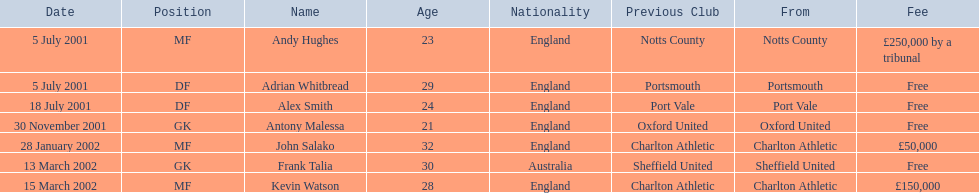Who are all the players? Andy Hughes, Adrian Whitbread, Alex Smith, Antony Malessa, John Salako, Frank Talia, Kevin Watson. What were their fees? £250,000 by a tribunal, Free, Free, Free, £50,000, Free, £150,000. Parse the full table. {'header': ['Date', 'Position', 'Name', 'Age', 'Nationality', 'Previous Club', 'From', 'Fee'], 'rows': [['5 July 2001', 'MF', 'Andy Hughes', '23', 'England', 'Notts County', 'Notts County', '£250,000 by a tribunal'], ['5 July 2001', 'DF', 'Adrian Whitbread', '29', 'England', 'Portsmouth', 'Portsmouth', 'Free'], ['18 July 2001', 'DF', 'Alex Smith', '24', 'England', 'Port Vale', 'Port Vale', 'Free'], ['30 November 2001', 'GK', 'Antony Malessa', '21', 'England', 'Oxford United', 'Oxford United', 'Free'], ['28 January 2002', 'MF', 'John Salako', '32', 'England', 'Charlton Athletic', 'Charlton Athletic', '£50,000'], ['13 March 2002', 'GK', 'Frank Talia', '30', 'Australia', 'Sheffield United', 'Sheffield United', 'Free'], ['15 March 2002', 'MF', 'Kevin Watson', '28', 'England', 'Charlton Athletic', 'Charlton Athletic', '£150,000']]} And how much was kevin watson's fee? £150,000. 